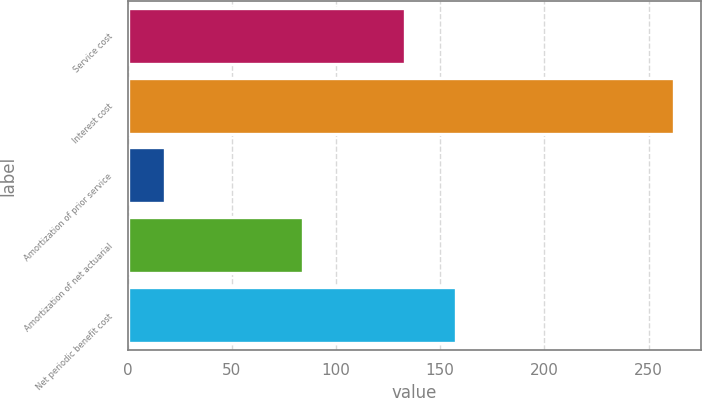<chart> <loc_0><loc_0><loc_500><loc_500><bar_chart><fcel>Service cost<fcel>Interest cost<fcel>Amortization of prior service<fcel>Amortization of net actuarial<fcel>Net periodic benefit cost<nl><fcel>133<fcel>262<fcel>18<fcel>84<fcel>157.4<nl></chart> 